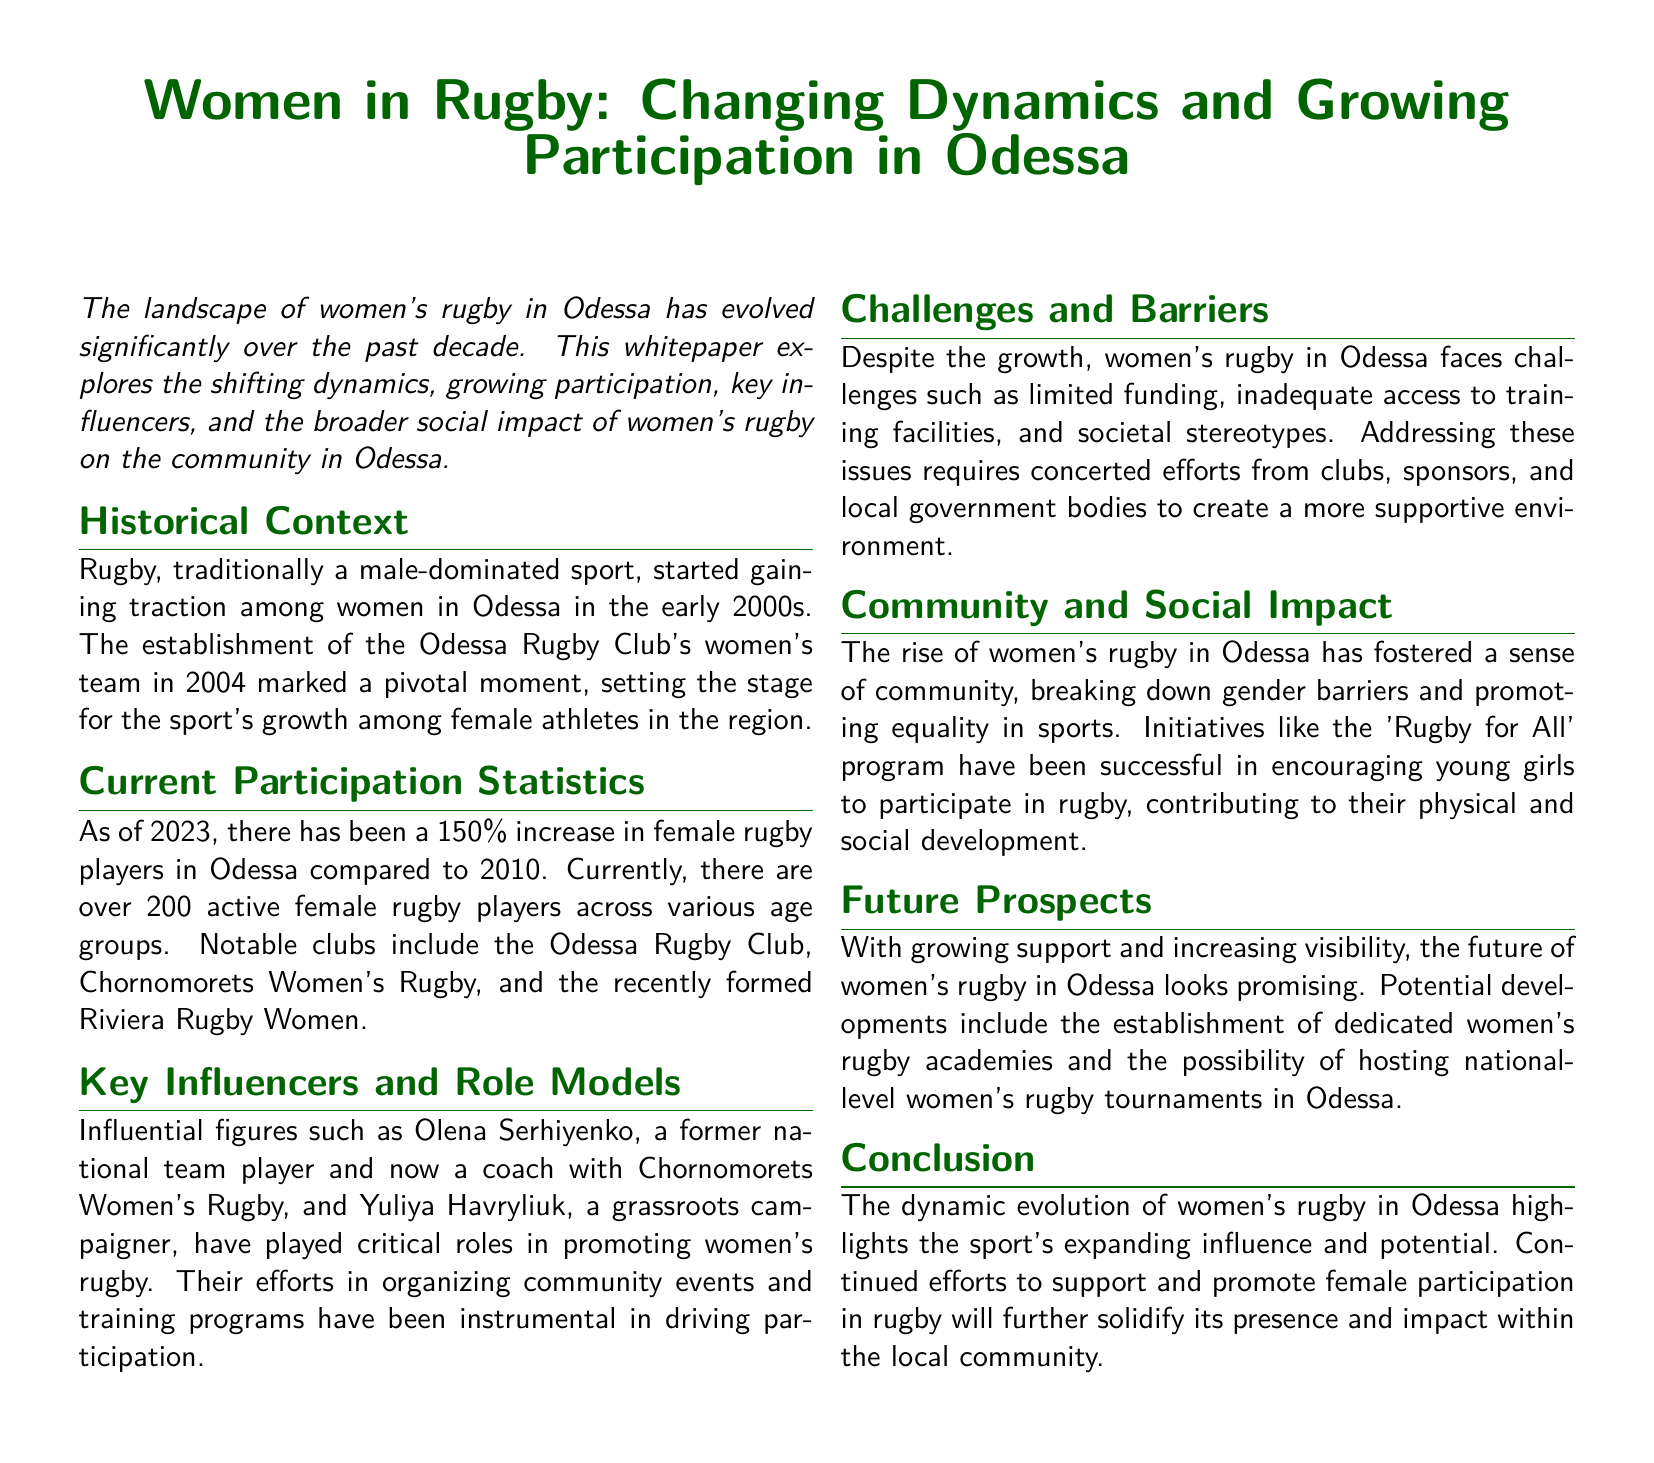What year was the Odessa Rugby Club's women's team established? The document mentions that the women's team was established in 2004, marking a pivotal moment for women's rugby in Odessa.
Answer: 2004 What is the percentage increase in female rugby players from 2010 to 2023? The document states that there has been a 150% increase in female rugby players in Odessa compared to 2010.
Answer: 150% How many active female rugby players are currently in Odessa? According to the document, there are over 200 active female rugby players across various age groups.
Answer: Over 200 Who is a notable coach mentioned in the document? The document highlights Olena Serhiyenko as a former national team player and a current coach who has influenced women's rugby in Odessa.
Answer: Olena Serhiyenko What is one of the key challenges faced by women's rugby in Odessa? The whitepaper lists limited funding as one of the challenges faced by women's rugby in Odessa.
Answer: Limited funding What program encourages young girls to participate in rugby? The document mentions the 'Rugby for All' program as an initiative that has been successful in encouraging participation among young girls.
Answer: Rugby for All What potential future development is mentioned for women's rugby in Odessa? The document suggests the establishment of dedicated women's rugby academies as a potential future development.
Answer: Dedicated women's rugby academies What impact has the rise of women's rugby had on the community? The whitepaper states that the rise of women's rugby has fostered a sense of community and promoted equality in sports.
Answer: Fostered a sense of community What role do local government bodies play in supporting women's rugby? The document implies that local government bodies need to create a more supportive environment for women in rugby, addressing challenges present in the sport.
Answer: Create a supportive environment 